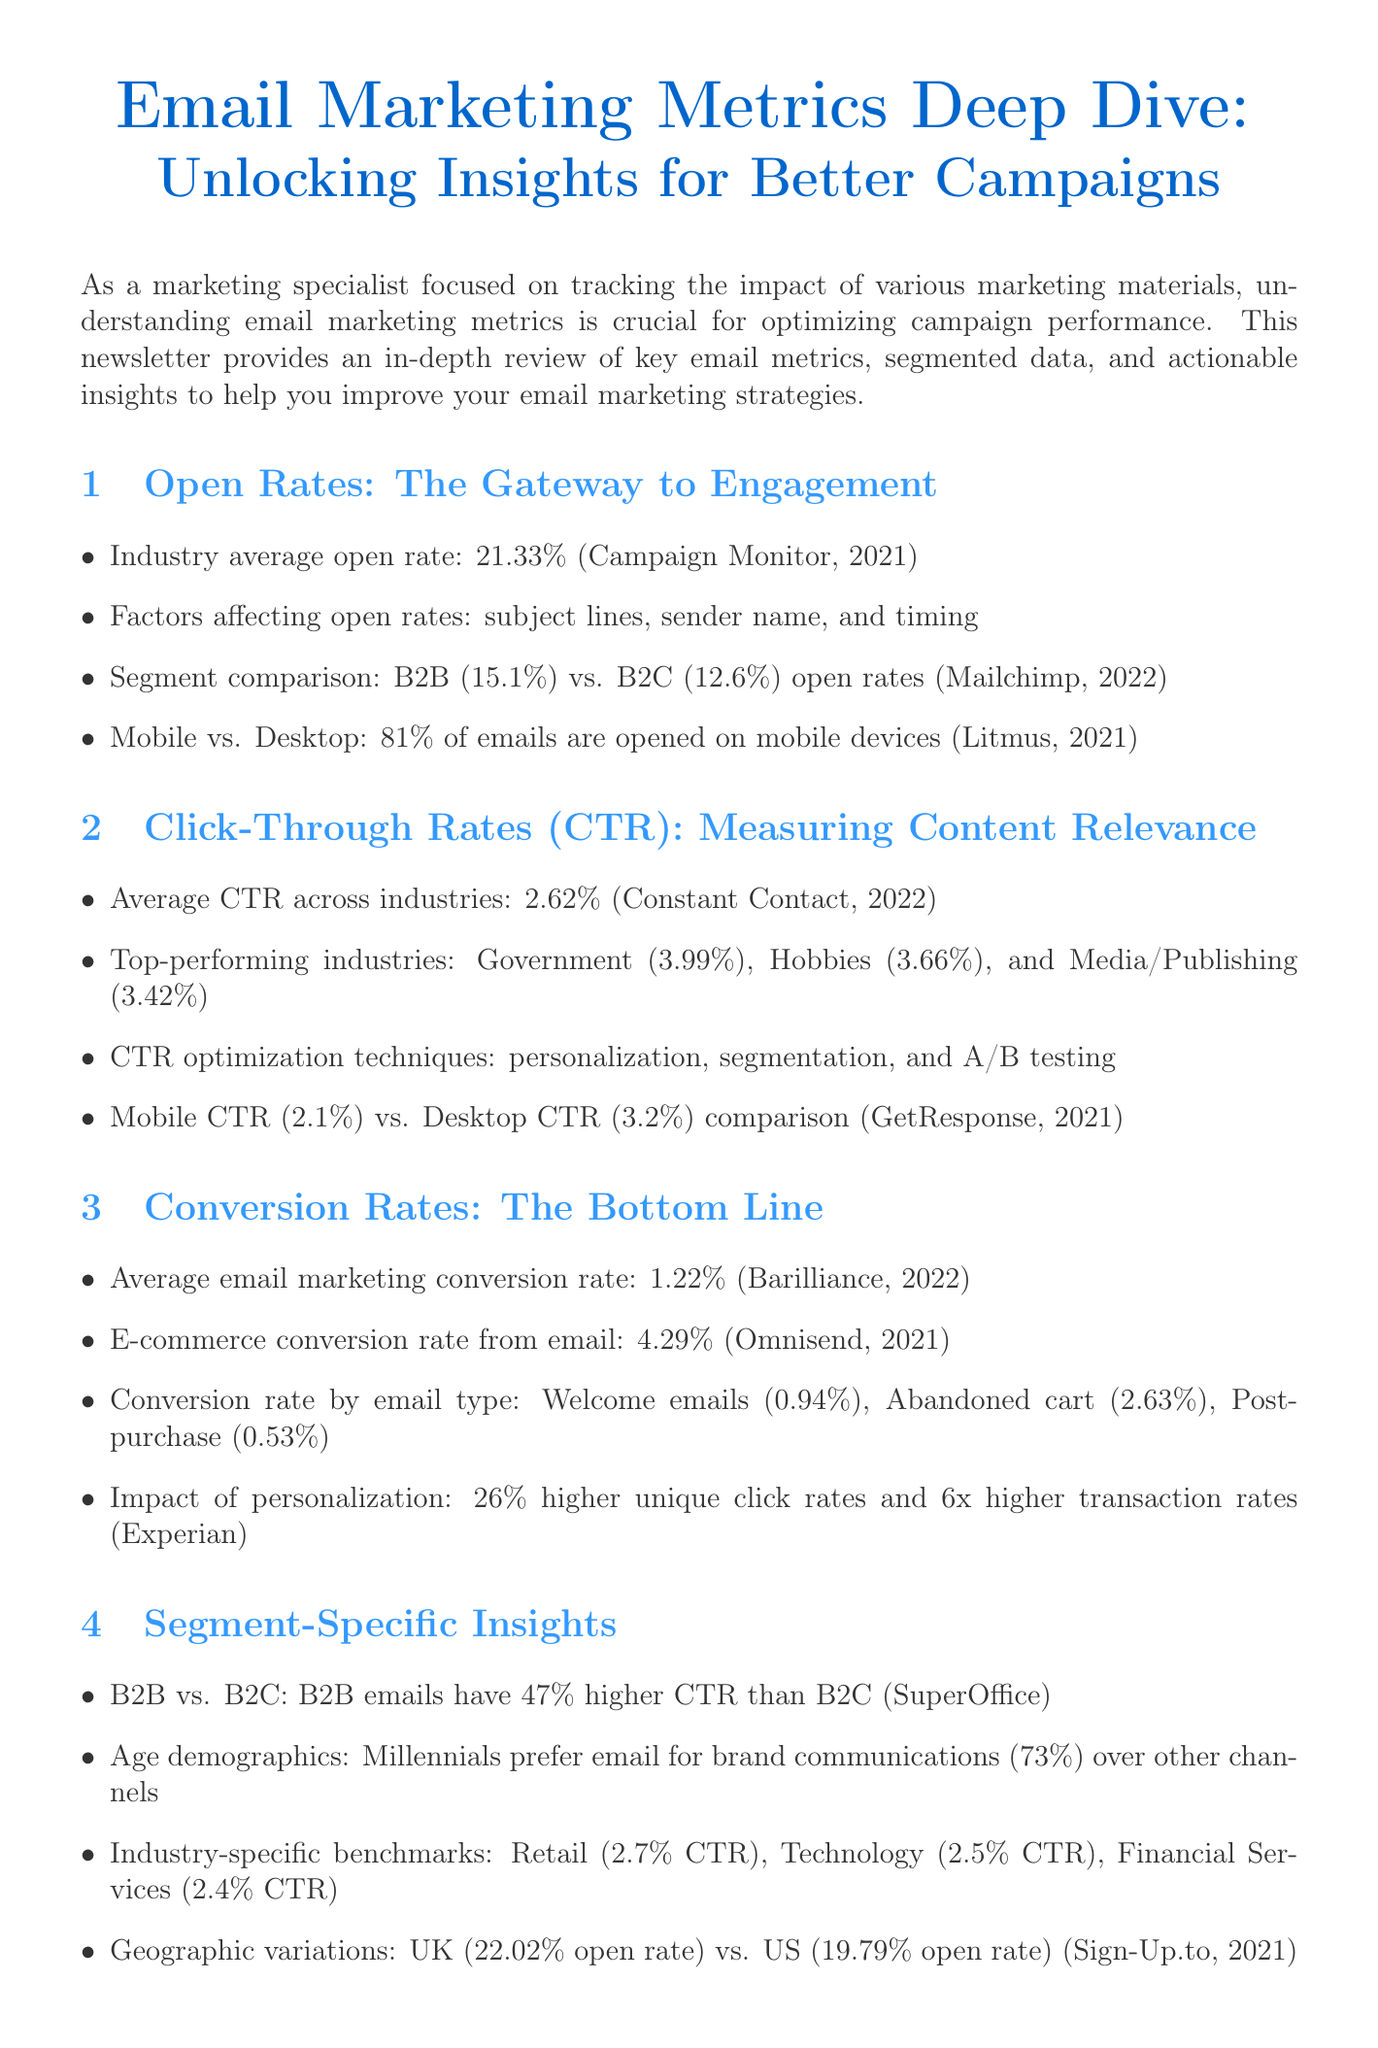What is the industry average open rate? The industry average open rate is the average value derived from multiple sources, specifically mentioned as 21.33%.
Answer: 21.33% What factors affect open rates? Factors influencing open rates include several elements, which are listed as subject lines, sender name, and timing.
Answer: subject lines, sender name, and timing Which segment has higher open rates, B2B or B2C? A direct comparison between B2B and B2C open rates indicates that B2B has a higher percentage.
Answer: B2B What is the average click-through rate across industries? The average click-through rate reflects a percentage indicating overall performance, specifically cited as 2.62%.
Answer: 2.62% What is the conversion rate of welcome emails? The document lists various conversion rates by email type and indicates the welcome email conversion rate specifically.
Answer: 0.94% Which industry has the highest average CTR? Among various industries listed, one is specifically noted for having the highest click-through rate.
Answer: Government What is the impact of personalization on transaction rates? The personalized marketing approach is associated with a significant increase in transaction rates, as indicated in the document.
Answer: 6x higher transaction rates What percentage of consumers share email offers with friends? The document provides a specific statistic about consumer behavior regarding sharing email offers.
Answer: 21% What is the recommended list growth rate? Suggested growth strategies for email lists are quantified in terms of percentage to maintain engagement levels.
Answer: 25% What is the average email marketing conversion rate? The average conversion rate for email marketing is specified, highlighting overall effectiveness for campaigns.
Answer: 1.22% 